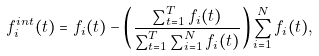Convert formula to latex. <formula><loc_0><loc_0><loc_500><loc_500>f _ { i } ^ { i n t } ( t ) = f _ { i } ( t ) - \left ( \frac { \sum _ { t = 1 } ^ { T } f _ { i } ( t ) } { \sum _ { t = 1 } ^ { T } \sum _ { i = 1 } ^ { N } f _ { i } ( t ) } \right ) \sum _ { i = 1 } ^ { N } f _ { i } ( t ) ,</formula> 